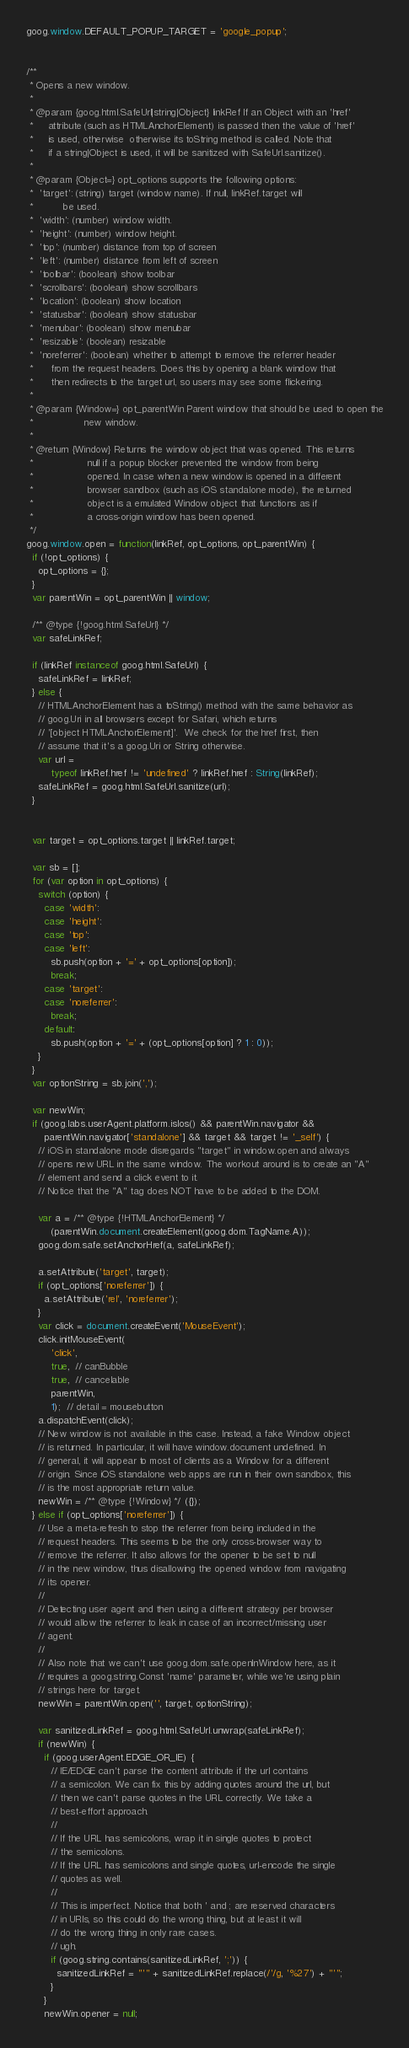<code> <loc_0><loc_0><loc_500><loc_500><_JavaScript_>goog.window.DEFAULT_POPUP_TARGET = 'google_popup';


/**
 * Opens a new window.
 *
 * @param {goog.html.SafeUrl|string|Object} linkRef If an Object with an 'href'
 *     attribute (such as HTMLAnchorElement) is passed then the value of 'href'
 *     is used, otherwise  otherwise its toString method is called. Note that
 *     if a string|Object is used, it will be sanitized with SafeUrl.sanitize().
 *
 * @param {Object=} opt_options supports the following options:
 *  'target': (string) target (window name). If null, linkRef.target will
 *          be used.
 *  'width': (number) window width.
 *  'height': (number) window height.
 *  'top': (number) distance from top of screen
 *  'left': (number) distance from left of screen
 *  'toolbar': (boolean) show toolbar
 *  'scrollbars': (boolean) show scrollbars
 *  'location': (boolean) show location
 *  'statusbar': (boolean) show statusbar
 *  'menubar': (boolean) show menubar
 *  'resizable': (boolean) resizable
 *  'noreferrer': (boolean) whether to attempt to remove the referrer header
 *      from the request headers. Does this by opening a blank window that
 *      then redirects to the target url, so users may see some flickering.
 *
 * @param {Window=} opt_parentWin Parent window that should be used to open the
 *                 new window.
 *
 * @return {Window} Returns the window object that was opened. This returns
 *                  null if a popup blocker prevented the window from being
 *                  opened. In case when a new window is opened in a different
 *                  browser sandbox (such as iOS standalone mode), the returned
 *                  object is a emulated Window object that functions as if
 *                  a cross-origin window has been opened.
 */
goog.window.open = function(linkRef, opt_options, opt_parentWin) {
  if (!opt_options) {
    opt_options = {};
  }
  var parentWin = opt_parentWin || window;

  /** @type {!goog.html.SafeUrl} */
  var safeLinkRef;

  if (linkRef instanceof goog.html.SafeUrl) {
    safeLinkRef = linkRef;
  } else {
    // HTMLAnchorElement has a toString() method with the same behavior as
    // goog.Uri in all browsers except for Safari, which returns
    // '[object HTMLAnchorElement]'.  We check for the href first, then
    // assume that it's a goog.Uri or String otherwise.
    var url =
        typeof linkRef.href != 'undefined' ? linkRef.href : String(linkRef);
    safeLinkRef = goog.html.SafeUrl.sanitize(url);
  }


  var target = opt_options.target || linkRef.target;

  var sb = [];
  for (var option in opt_options) {
    switch (option) {
      case 'width':
      case 'height':
      case 'top':
      case 'left':
        sb.push(option + '=' + opt_options[option]);
        break;
      case 'target':
      case 'noreferrer':
        break;
      default:
        sb.push(option + '=' + (opt_options[option] ? 1 : 0));
    }
  }
  var optionString = sb.join(',');

  var newWin;
  if (goog.labs.userAgent.platform.isIos() && parentWin.navigator &&
      parentWin.navigator['standalone'] && target && target != '_self') {
    // iOS in standalone mode disregards "target" in window.open and always
    // opens new URL in the same window. The workout around is to create an "A"
    // element and send a click event to it.
    // Notice that the "A" tag does NOT have to be added to the DOM.

    var a = /** @type {!HTMLAnchorElement} */
        (parentWin.document.createElement(goog.dom.TagName.A));
    goog.dom.safe.setAnchorHref(a, safeLinkRef);

    a.setAttribute('target', target);
    if (opt_options['noreferrer']) {
      a.setAttribute('rel', 'noreferrer');
    }
    var click = document.createEvent('MouseEvent');
    click.initMouseEvent(
        'click',
        true,  // canBubble
        true,  // cancelable
        parentWin,
        1);  // detail = mousebutton
    a.dispatchEvent(click);
    // New window is not available in this case. Instead, a fake Window object
    // is returned. In particular, it will have window.document undefined. In
    // general, it will appear to most of clients as a Window for a different
    // origin. Since iOS standalone web apps are run in their own sandbox, this
    // is the most appropriate return value.
    newWin = /** @type {!Window} */ ({});
  } else if (opt_options['noreferrer']) {
    // Use a meta-refresh to stop the referrer from being included in the
    // request headers. This seems to be the only cross-browser way to
    // remove the referrer. It also allows for the opener to be set to null
    // in the new window, thus disallowing the opened window from navigating
    // its opener.
    //
    // Detecting user agent and then using a different strategy per browser
    // would allow the referrer to leak in case of an incorrect/missing user
    // agent.
    //
    // Also note that we can't use goog.dom.safe.openInWindow here, as it
    // requires a goog.string.Const 'name' parameter, while we're using plain
    // strings here for target.
    newWin = parentWin.open('', target, optionString);

    var sanitizedLinkRef = goog.html.SafeUrl.unwrap(safeLinkRef);
    if (newWin) {
      if (goog.userAgent.EDGE_OR_IE) {
        // IE/EDGE can't parse the content attribute if the url contains
        // a semicolon. We can fix this by adding quotes around the url, but
        // then we can't parse quotes in the URL correctly. We take a
        // best-effort approach.
        //
        // If the URL has semicolons, wrap it in single quotes to protect
        // the semicolons.
        // If the URL has semicolons and single quotes, url-encode the single
        // quotes as well.
        //
        // This is imperfect. Notice that both ' and ; are reserved characters
        // in URIs, so this could do the wrong thing, but at least it will
        // do the wrong thing in only rare cases.
        // ugh.
        if (goog.string.contains(sanitizedLinkRef, ';')) {
          sanitizedLinkRef = "'" + sanitizedLinkRef.replace(/'/g, '%27') + "'";
        }
      }
      newWin.opener = null;
</code> 